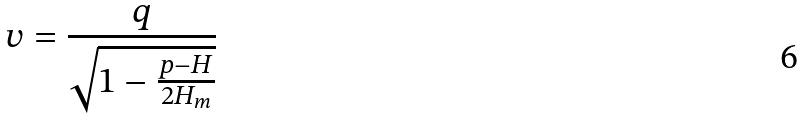<formula> <loc_0><loc_0><loc_500><loc_500>v = \frac { q } { \sqrt { 1 - \frac { p - H } { 2 H _ { m } } } }</formula> 